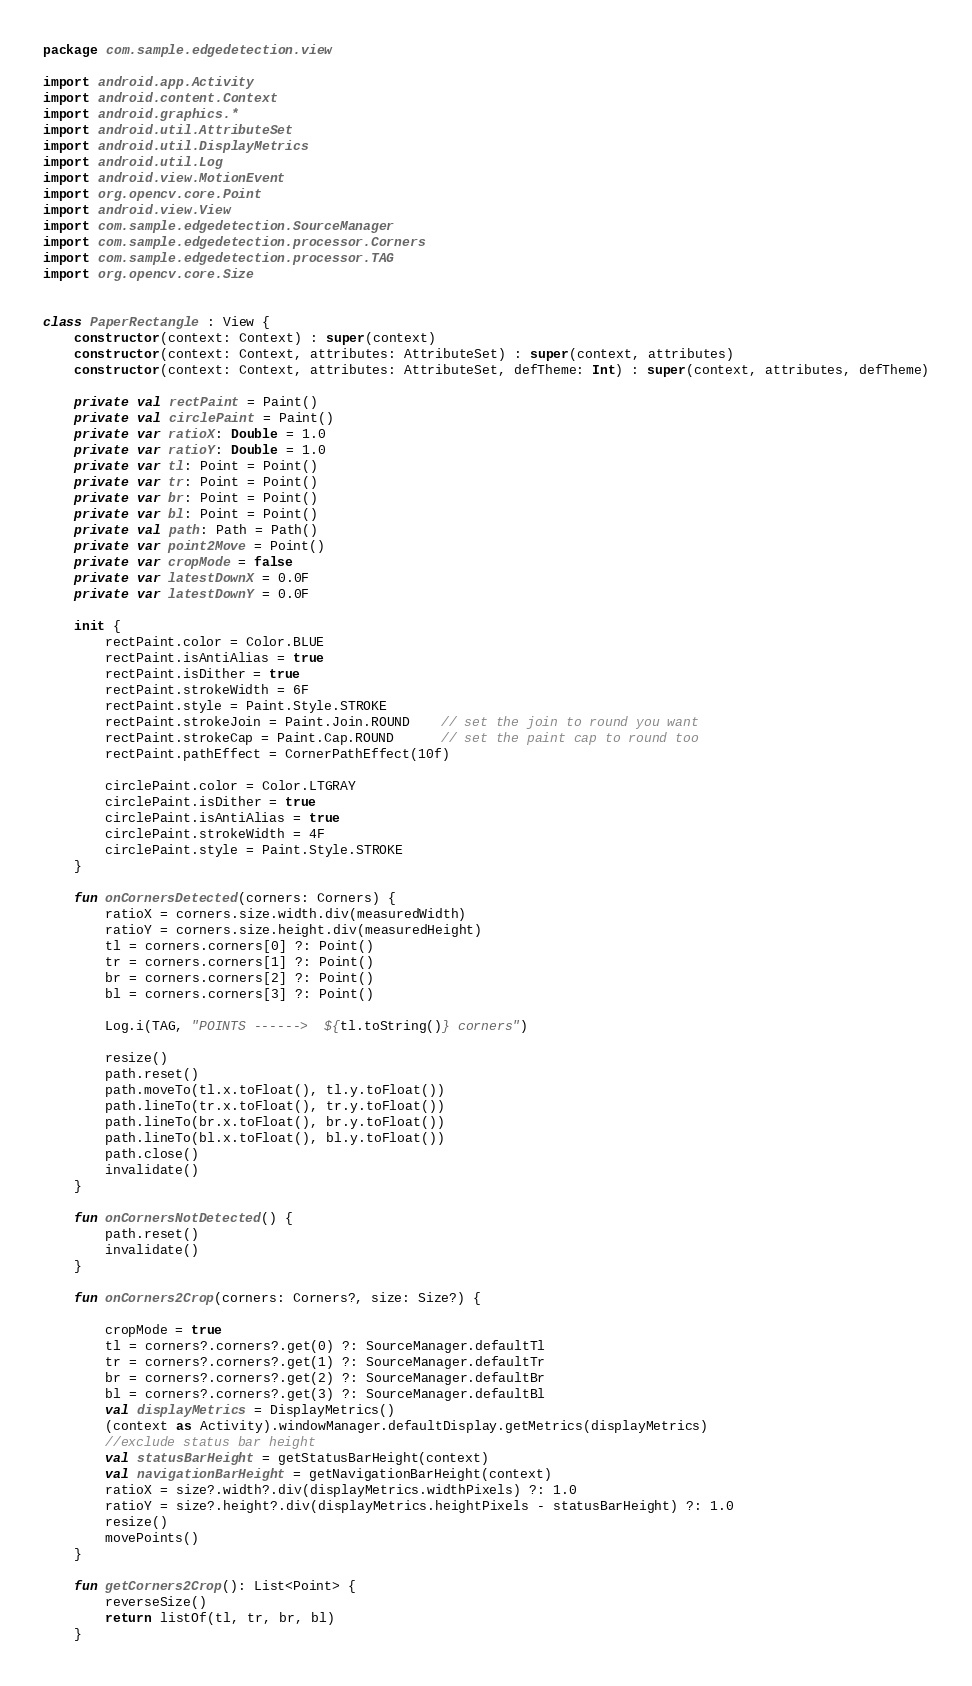Convert code to text. <code><loc_0><loc_0><loc_500><loc_500><_Kotlin_>package com.sample.edgedetection.view

import android.app.Activity
import android.content.Context
import android.graphics.*
import android.util.AttributeSet
import android.util.DisplayMetrics
import android.util.Log
import android.view.MotionEvent
import org.opencv.core.Point
import android.view.View
import com.sample.edgedetection.SourceManager
import com.sample.edgedetection.processor.Corners
import com.sample.edgedetection.processor.TAG
import org.opencv.core.Size


class PaperRectangle : View {
    constructor(context: Context) : super(context)
    constructor(context: Context, attributes: AttributeSet) : super(context, attributes)
    constructor(context: Context, attributes: AttributeSet, defTheme: Int) : super(context, attributes, defTheme)

    private val rectPaint = Paint()
    private val circlePaint = Paint()
    private var ratioX: Double = 1.0
    private var ratioY: Double = 1.0
    private var tl: Point = Point()
    private var tr: Point = Point()
    private var br: Point = Point()
    private var bl: Point = Point()
    private val path: Path = Path()
    private var point2Move = Point()
    private var cropMode = false
    private var latestDownX = 0.0F
    private var latestDownY = 0.0F

    init {
        rectPaint.color = Color.BLUE
        rectPaint.isAntiAlias = true
        rectPaint.isDither = true
        rectPaint.strokeWidth = 6F
        rectPaint.style = Paint.Style.STROKE
        rectPaint.strokeJoin = Paint.Join.ROUND    // set the join to round you want
        rectPaint.strokeCap = Paint.Cap.ROUND      // set the paint cap to round too
        rectPaint.pathEffect = CornerPathEffect(10f)

        circlePaint.color = Color.LTGRAY
        circlePaint.isDither = true
        circlePaint.isAntiAlias = true
        circlePaint.strokeWidth = 4F
        circlePaint.style = Paint.Style.STROKE
    }

    fun onCornersDetected(corners: Corners) {
        ratioX = corners.size.width.div(measuredWidth)
        ratioY = corners.size.height.div(measuredHeight)
        tl = corners.corners[0] ?: Point()
        tr = corners.corners[1] ?: Point()
        br = corners.corners[2] ?: Point()
        bl = corners.corners[3] ?: Point()

        Log.i(TAG, "POINTS ------>  ${tl.toString()} corners")
        
        resize()
        path.reset()
        path.moveTo(tl.x.toFloat(), tl.y.toFloat())
        path.lineTo(tr.x.toFloat(), tr.y.toFloat())
        path.lineTo(br.x.toFloat(), br.y.toFloat())
        path.lineTo(bl.x.toFloat(), bl.y.toFloat())
        path.close()
        invalidate()
    }

    fun onCornersNotDetected() {
        path.reset()
        invalidate()
    }

    fun onCorners2Crop(corners: Corners?, size: Size?) {

        cropMode = true
        tl = corners?.corners?.get(0) ?: SourceManager.defaultTl
        tr = corners?.corners?.get(1) ?: SourceManager.defaultTr
        br = corners?.corners?.get(2) ?: SourceManager.defaultBr
        bl = corners?.corners?.get(3) ?: SourceManager.defaultBl
        val displayMetrics = DisplayMetrics()
        (context as Activity).windowManager.defaultDisplay.getMetrics(displayMetrics)
        //exclude status bar height
        val statusBarHeight = getStatusBarHeight(context)
        val navigationBarHeight = getNavigationBarHeight(context)
        ratioX = size?.width?.div(displayMetrics.widthPixels) ?: 1.0
        ratioY = size?.height?.div(displayMetrics.heightPixels - statusBarHeight) ?: 1.0
        resize()
        movePoints()
    }

    fun getCorners2Crop(): List<Point> {
        reverseSize()
        return listOf(tl, tr, br, bl)
    }
</code> 